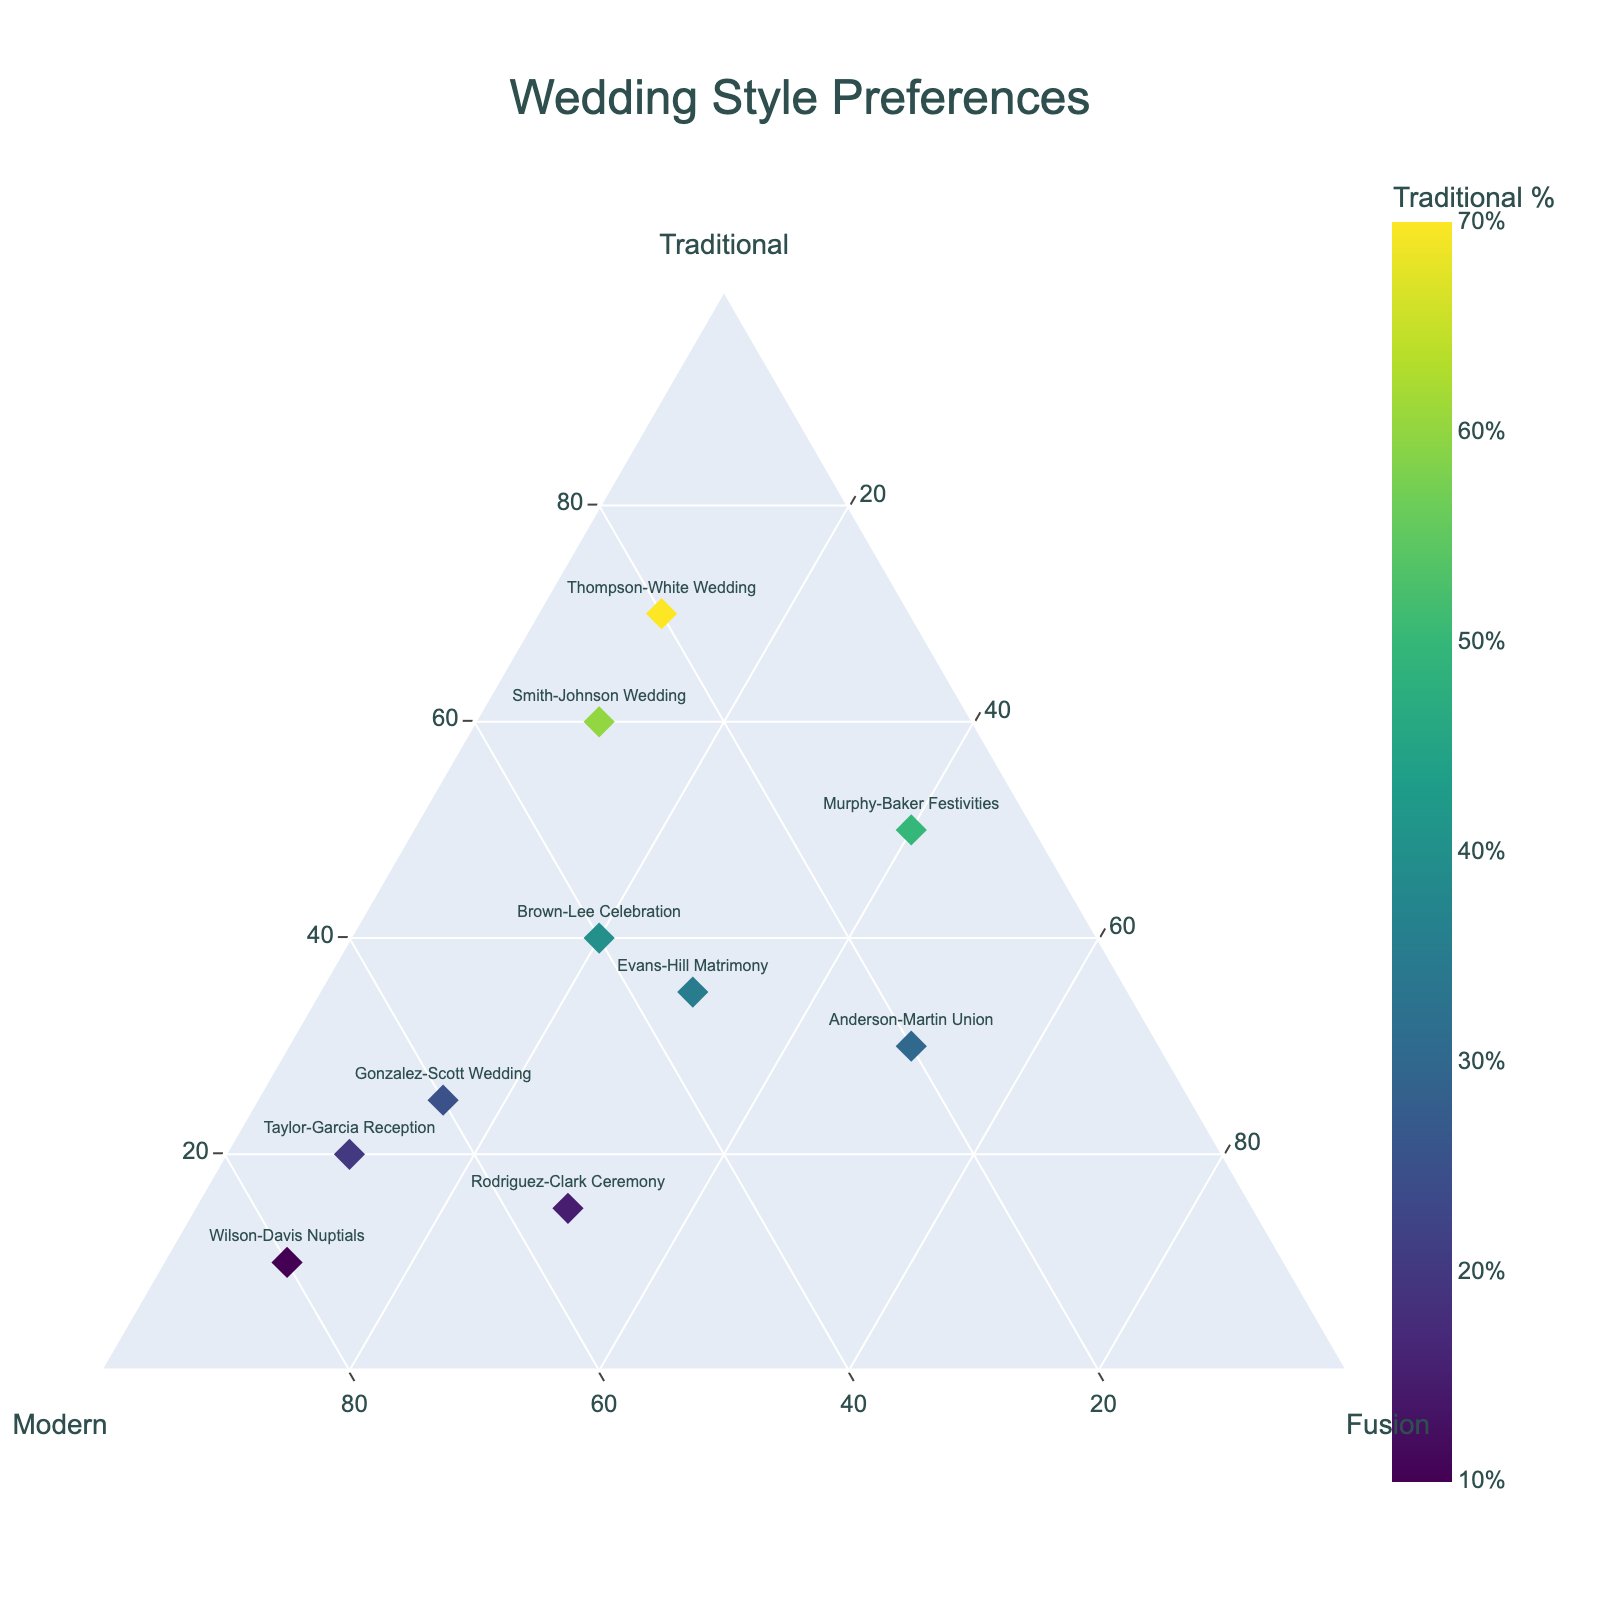what is the title of the plot? The title of the plot is usually positioned at the top center of the figure. Here, it reads "Wedding Style Preferences"
Answer: Wedding Style Preferences How many clients are represented in the plot? You can count the number of distinct labels or markers on the plot to determine the number of clients. There are 10 different clients listed in the data.
Answer: 10 Which wedding has the highest percentage of modern preferences? To find the wedding with the highest percentage of modern preferences, look at the 'modern' axis and identify the point closest to 100%. The Wilson-Davis Nuptials has 80% modern preferences.
Answer: Wilson-Davis Nuptials Which client prefers the highest percentage of fusion style? To determine which client prefers the fusion style the most, look at the 'fusion' axis and identify the point closest to 100%. The Anderson-Martin Union has 50% fusion preferences.
Answer: Anderson-Martin Union What is the sum of percentages for traditional and modern styles for the Gonzalez-Scott Wedding? The sum is calculated by adding the percentage of traditional (25%) and modern (60%) styles for the Gonzalez-Scott Wedding. So, 25% + 60% = 85%.
Answer: 85% Which weddings have an equal preference for traditional and modern styles? To identify weddings with equal preferences for traditional and modern styles, look for points where the traditional and modern percentages are the same. The Brown-Lee Celebration has 40% traditional and 40% modern preferences.
Answer: Brown-Lee Celebration What is the range of traditional preference percentages among the clients? The range is found by subtracting the lowest percentage of traditional preference (10%) from the highest percentage (70%) among the clients. So, 70% - 10% = 60%.
Answer: 60% Are there any clients who have a higher preference for fusion style compared to traditional? You need to identify clients where the fusion percentage is higher than the traditional percentage. The Anderson-Martin Union has 50% fusion and 30% traditional preferences.
Answer: Anderson-Martin Union Which wedding has the most balanced preference among traditional, modern, and fusion styles? A balanced preference is defined as having percentages near each other. The Evans-Hill Matrimony has 35% traditional, 35% modern, and 30% fusion preferences, which are the closest in value.
Answer: Evans-Hill Matrimony How does the Taylor-Garcia Reception's preferences compare to the Smith-Johnson Wedding? To compare, note the Taylor-Garcia Reception’s 20% traditional, 70% modern, and 10% fusion preferences against the Smith-Johnson Wedding’s 60% traditional, 30% modern, and 10% fusion. The Taylor-Garcia Reception has less traditional and more modern preferences than the Smith-Johnson Wedding, with the same fusion preference.
Answer: Taylor-Garcia Reception has less traditional and more modern preferences 